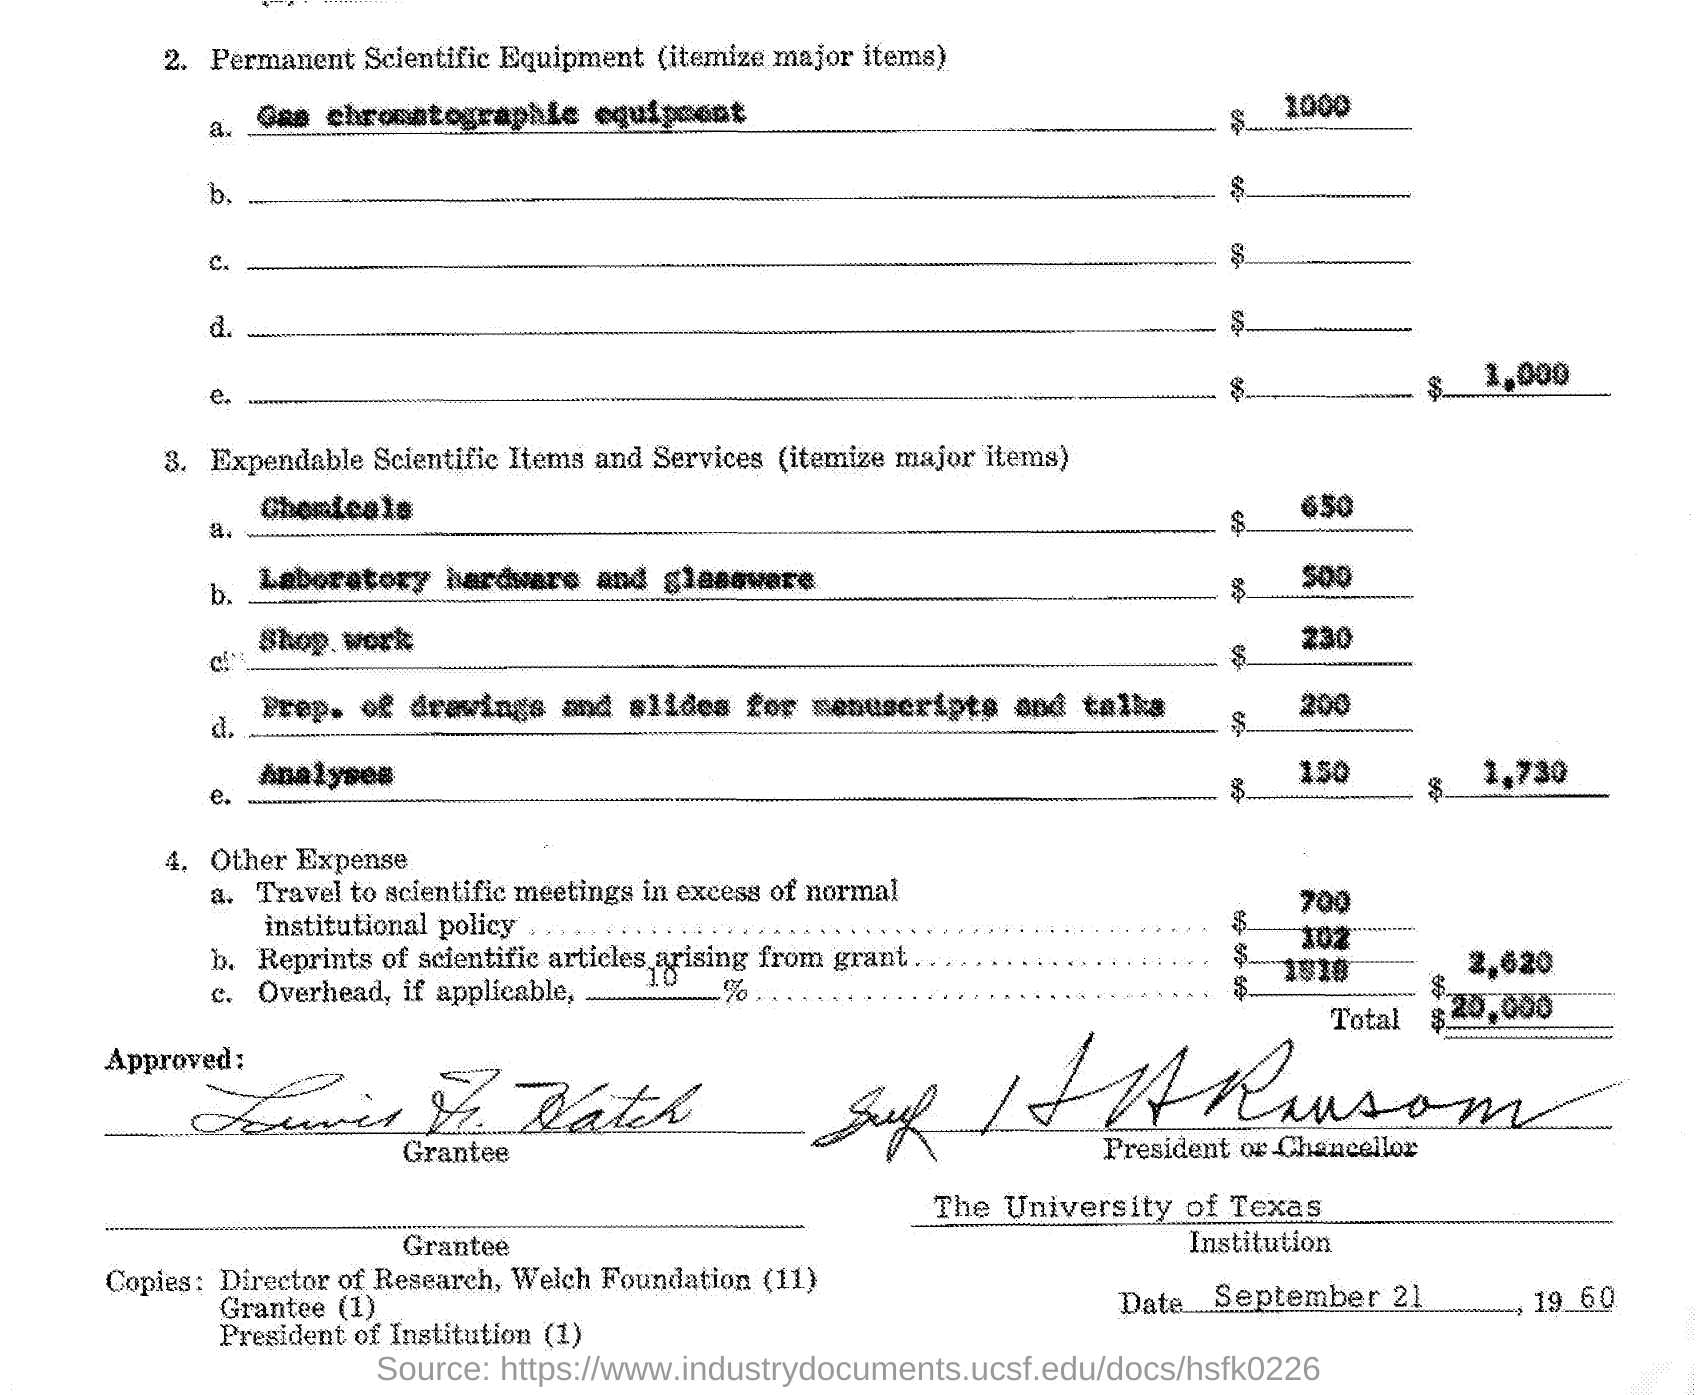Point out several critical features in this image. The date mentioned in the given page is September 21, 1960. The cost of chemicals is $650. The total cost of expandable scientific items and services is $1730. The cost of shop work is $230. The cost of reprints of scientific articles resulting from a grant is approximately $102. 